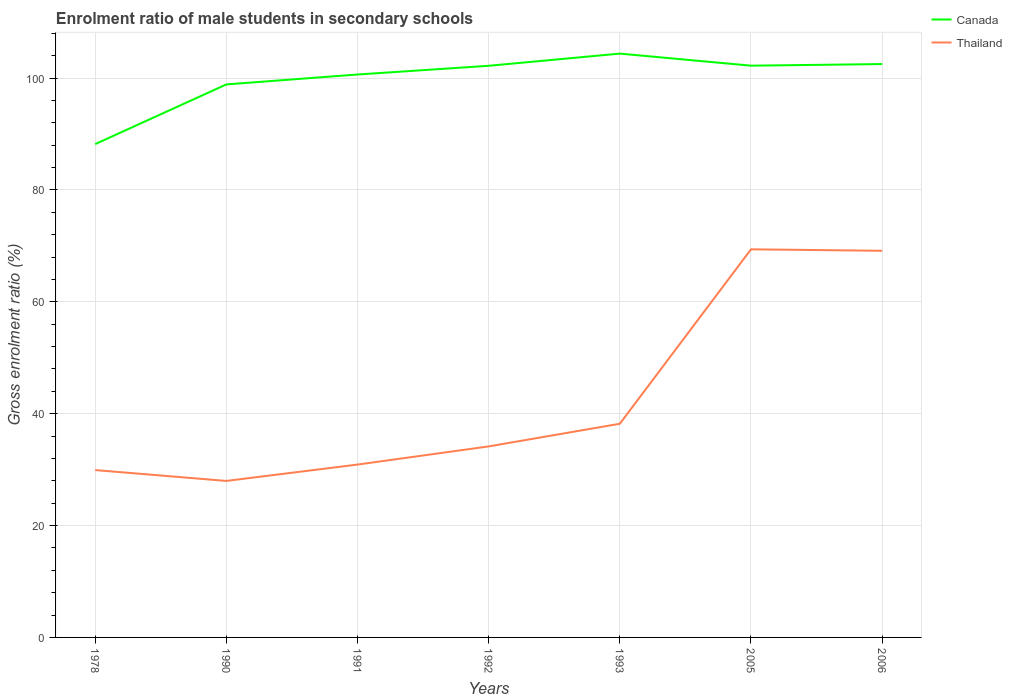How many different coloured lines are there?
Give a very brief answer. 2. Does the line corresponding to Thailand intersect with the line corresponding to Canada?
Make the answer very short. No. Across all years, what is the maximum enrolment ratio of male students in secondary schools in Thailand?
Ensure brevity in your answer.  27.98. What is the total enrolment ratio of male students in secondary schools in Canada in the graph?
Your answer should be very brief. -2.18. What is the difference between the highest and the second highest enrolment ratio of male students in secondary schools in Thailand?
Your answer should be compact. 41.41. What is the difference between the highest and the lowest enrolment ratio of male students in secondary schools in Canada?
Make the answer very short. 5. Are the values on the major ticks of Y-axis written in scientific E-notation?
Ensure brevity in your answer.  No. Where does the legend appear in the graph?
Provide a short and direct response. Top right. How many legend labels are there?
Make the answer very short. 2. What is the title of the graph?
Ensure brevity in your answer.  Enrolment ratio of male students in secondary schools. What is the label or title of the X-axis?
Ensure brevity in your answer.  Years. What is the Gross enrolment ratio (%) in Canada in 1978?
Make the answer very short. 88.2. What is the Gross enrolment ratio (%) in Thailand in 1978?
Offer a very short reply. 29.92. What is the Gross enrolment ratio (%) of Canada in 1990?
Give a very brief answer. 98.87. What is the Gross enrolment ratio (%) in Thailand in 1990?
Keep it short and to the point. 27.98. What is the Gross enrolment ratio (%) of Canada in 1991?
Provide a short and direct response. 100.64. What is the Gross enrolment ratio (%) of Thailand in 1991?
Keep it short and to the point. 30.91. What is the Gross enrolment ratio (%) in Canada in 1992?
Ensure brevity in your answer.  102.2. What is the Gross enrolment ratio (%) of Thailand in 1992?
Your response must be concise. 34.15. What is the Gross enrolment ratio (%) of Canada in 1993?
Your answer should be very brief. 104.38. What is the Gross enrolment ratio (%) in Thailand in 1993?
Give a very brief answer. 38.2. What is the Gross enrolment ratio (%) in Canada in 2005?
Give a very brief answer. 102.22. What is the Gross enrolment ratio (%) of Thailand in 2005?
Provide a succinct answer. 69.39. What is the Gross enrolment ratio (%) in Canada in 2006?
Make the answer very short. 102.51. What is the Gross enrolment ratio (%) of Thailand in 2006?
Offer a very short reply. 69.12. Across all years, what is the maximum Gross enrolment ratio (%) in Canada?
Your answer should be very brief. 104.38. Across all years, what is the maximum Gross enrolment ratio (%) in Thailand?
Keep it short and to the point. 69.39. Across all years, what is the minimum Gross enrolment ratio (%) in Canada?
Make the answer very short. 88.2. Across all years, what is the minimum Gross enrolment ratio (%) of Thailand?
Make the answer very short. 27.98. What is the total Gross enrolment ratio (%) in Canada in the graph?
Your answer should be compact. 699.02. What is the total Gross enrolment ratio (%) in Thailand in the graph?
Give a very brief answer. 299.67. What is the difference between the Gross enrolment ratio (%) of Canada in 1978 and that in 1990?
Your answer should be compact. -10.67. What is the difference between the Gross enrolment ratio (%) in Thailand in 1978 and that in 1990?
Give a very brief answer. 1.94. What is the difference between the Gross enrolment ratio (%) of Canada in 1978 and that in 1991?
Keep it short and to the point. -12.44. What is the difference between the Gross enrolment ratio (%) of Thailand in 1978 and that in 1991?
Keep it short and to the point. -0.99. What is the difference between the Gross enrolment ratio (%) of Canada in 1978 and that in 1992?
Ensure brevity in your answer.  -14. What is the difference between the Gross enrolment ratio (%) of Thailand in 1978 and that in 1992?
Make the answer very short. -4.23. What is the difference between the Gross enrolment ratio (%) in Canada in 1978 and that in 1993?
Offer a terse response. -16.18. What is the difference between the Gross enrolment ratio (%) in Thailand in 1978 and that in 1993?
Give a very brief answer. -8.28. What is the difference between the Gross enrolment ratio (%) in Canada in 1978 and that in 2005?
Give a very brief answer. -14.02. What is the difference between the Gross enrolment ratio (%) of Thailand in 1978 and that in 2005?
Your response must be concise. -39.47. What is the difference between the Gross enrolment ratio (%) in Canada in 1978 and that in 2006?
Keep it short and to the point. -14.31. What is the difference between the Gross enrolment ratio (%) in Thailand in 1978 and that in 2006?
Keep it short and to the point. -39.2. What is the difference between the Gross enrolment ratio (%) of Canada in 1990 and that in 1991?
Give a very brief answer. -1.77. What is the difference between the Gross enrolment ratio (%) of Thailand in 1990 and that in 1991?
Provide a succinct answer. -2.93. What is the difference between the Gross enrolment ratio (%) of Canada in 1990 and that in 1992?
Offer a terse response. -3.33. What is the difference between the Gross enrolment ratio (%) of Thailand in 1990 and that in 1992?
Provide a succinct answer. -6.17. What is the difference between the Gross enrolment ratio (%) in Canada in 1990 and that in 1993?
Your answer should be compact. -5.51. What is the difference between the Gross enrolment ratio (%) in Thailand in 1990 and that in 1993?
Offer a terse response. -10.22. What is the difference between the Gross enrolment ratio (%) in Canada in 1990 and that in 2005?
Provide a short and direct response. -3.35. What is the difference between the Gross enrolment ratio (%) in Thailand in 1990 and that in 2005?
Keep it short and to the point. -41.41. What is the difference between the Gross enrolment ratio (%) of Canada in 1990 and that in 2006?
Provide a short and direct response. -3.64. What is the difference between the Gross enrolment ratio (%) of Thailand in 1990 and that in 2006?
Offer a very short reply. -41.14. What is the difference between the Gross enrolment ratio (%) of Canada in 1991 and that in 1992?
Offer a terse response. -1.56. What is the difference between the Gross enrolment ratio (%) in Thailand in 1991 and that in 1992?
Make the answer very short. -3.25. What is the difference between the Gross enrolment ratio (%) in Canada in 1991 and that in 1993?
Provide a succinct answer. -3.73. What is the difference between the Gross enrolment ratio (%) in Thailand in 1991 and that in 1993?
Make the answer very short. -7.3. What is the difference between the Gross enrolment ratio (%) of Canada in 1991 and that in 2005?
Provide a succinct answer. -1.58. What is the difference between the Gross enrolment ratio (%) of Thailand in 1991 and that in 2005?
Give a very brief answer. -38.48. What is the difference between the Gross enrolment ratio (%) in Canada in 1991 and that in 2006?
Your answer should be very brief. -1.87. What is the difference between the Gross enrolment ratio (%) in Thailand in 1991 and that in 2006?
Offer a terse response. -38.22. What is the difference between the Gross enrolment ratio (%) in Canada in 1992 and that in 1993?
Your answer should be compact. -2.18. What is the difference between the Gross enrolment ratio (%) of Thailand in 1992 and that in 1993?
Ensure brevity in your answer.  -4.05. What is the difference between the Gross enrolment ratio (%) of Canada in 1992 and that in 2005?
Offer a very short reply. -0.02. What is the difference between the Gross enrolment ratio (%) in Thailand in 1992 and that in 2005?
Ensure brevity in your answer.  -35.24. What is the difference between the Gross enrolment ratio (%) of Canada in 1992 and that in 2006?
Your answer should be very brief. -0.31. What is the difference between the Gross enrolment ratio (%) of Thailand in 1992 and that in 2006?
Keep it short and to the point. -34.97. What is the difference between the Gross enrolment ratio (%) in Canada in 1993 and that in 2005?
Your answer should be very brief. 2.16. What is the difference between the Gross enrolment ratio (%) in Thailand in 1993 and that in 2005?
Your answer should be very brief. -31.19. What is the difference between the Gross enrolment ratio (%) of Canada in 1993 and that in 2006?
Offer a terse response. 1.87. What is the difference between the Gross enrolment ratio (%) of Thailand in 1993 and that in 2006?
Provide a short and direct response. -30.92. What is the difference between the Gross enrolment ratio (%) in Canada in 2005 and that in 2006?
Your response must be concise. -0.29. What is the difference between the Gross enrolment ratio (%) of Thailand in 2005 and that in 2006?
Your answer should be compact. 0.27. What is the difference between the Gross enrolment ratio (%) of Canada in 1978 and the Gross enrolment ratio (%) of Thailand in 1990?
Give a very brief answer. 60.22. What is the difference between the Gross enrolment ratio (%) of Canada in 1978 and the Gross enrolment ratio (%) of Thailand in 1991?
Offer a very short reply. 57.29. What is the difference between the Gross enrolment ratio (%) of Canada in 1978 and the Gross enrolment ratio (%) of Thailand in 1992?
Your answer should be very brief. 54.05. What is the difference between the Gross enrolment ratio (%) in Canada in 1978 and the Gross enrolment ratio (%) in Thailand in 1993?
Provide a short and direct response. 50. What is the difference between the Gross enrolment ratio (%) in Canada in 1978 and the Gross enrolment ratio (%) in Thailand in 2005?
Make the answer very short. 18.81. What is the difference between the Gross enrolment ratio (%) in Canada in 1978 and the Gross enrolment ratio (%) in Thailand in 2006?
Your answer should be very brief. 19.08. What is the difference between the Gross enrolment ratio (%) in Canada in 1990 and the Gross enrolment ratio (%) in Thailand in 1991?
Your answer should be very brief. 67.97. What is the difference between the Gross enrolment ratio (%) of Canada in 1990 and the Gross enrolment ratio (%) of Thailand in 1992?
Provide a short and direct response. 64.72. What is the difference between the Gross enrolment ratio (%) in Canada in 1990 and the Gross enrolment ratio (%) in Thailand in 1993?
Keep it short and to the point. 60.67. What is the difference between the Gross enrolment ratio (%) of Canada in 1990 and the Gross enrolment ratio (%) of Thailand in 2005?
Provide a short and direct response. 29.48. What is the difference between the Gross enrolment ratio (%) in Canada in 1990 and the Gross enrolment ratio (%) in Thailand in 2006?
Your answer should be very brief. 29.75. What is the difference between the Gross enrolment ratio (%) in Canada in 1991 and the Gross enrolment ratio (%) in Thailand in 1992?
Give a very brief answer. 66.49. What is the difference between the Gross enrolment ratio (%) in Canada in 1991 and the Gross enrolment ratio (%) in Thailand in 1993?
Make the answer very short. 62.44. What is the difference between the Gross enrolment ratio (%) of Canada in 1991 and the Gross enrolment ratio (%) of Thailand in 2005?
Make the answer very short. 31.25. What is the difference between the Gross enrolment ratio (%) of Canada in 1991 and the Gross enrolment ratio (%) of Thailand in 2006?
Ensure brevity in your answer.  31.52. What is the difference between the Gross enrolment ratio (%) of Canada in 1992 and the Gross enrolment ratio (%) of Thailand in 1993?
Provide a succinct answer. 64. What is the difference between the Gross enrolment ratio (%) in Canada in 1992 and the Gross enrolment ratio (%) in Thailand in 2005?
Your response must be concise. 32.81. What is the difference between the Gross enrolment ratio (%) in Canada in 1992 and the Gross enrolment ratio (%) in Thailand in 2006?
Keep it short and to the point. 33.08. What is the difference between the Gross enrolment ratio (%) in Canada in 1993 and the Gross enrolment ratio (%) in Thailand in 2005?
Offer a terse response. 34.99. What is the difference between the Gross enrolment ratio (%) of Canada in 1993 and the Gross enrolment ratio (%) of Thailand in 2006?
Your response must be concise. 35.25. What is the difference between the Gross enrolment ratio (%) in Canada in 2005 and the Gross enrolment ratio (%) in Thailand in 2006?
Your answer should be very brief. 33.1. What is the average Gross enrolment ratio (%) in Canada per year?
Make the answer very short. 99.86. What is the average Gross enrolment ratio (%) in Thailand per year?
Ensure brevity in your answer.  42.81. In the year 1978, what is the difference between the Gross enrolment ratio (%) of Canada and Gross enrolment ratio (%) of Thailand?
Make the answer very short. 58.28. In the year 1990, what is the difference between the Gross enrolment ratio (%) of Canada and Gross enrolment ratio (%) of Thailand?
Ensure brevity in your answer.  70.89. In the year 1991, what is the difference between the Gross enrolment ratio (%) in Canada and Gross enrolment ratio (%) in Thailand?
Give a very brief answer. 69.74. In the year 1992, what is the difference between the Gross enrolment ratio (%) of Canada and Gross enrolment ratio (%) of Thailand?
Give a very brief answer. 68.05. In the year 1993, what is the difference between the Gross enrolment ratio (%) in Canada and Gross enrolment ratio (%) in Thailand?
Offer a very short reply. 66.17. In the year 2005, what is the difference between the Gross enrolment ratio (%) of Canada and Gross enrolment ratio (%) of Thailand?
Offer a terse response. 32.83. In the year 2006, what is the difference between the Gross enrolment ratio (%) in Canada and Gross enrolment ratio (%) in Thailand?
Provide a succinct answer. 33.39. What is the ratio of the Gross enrolment ratio (%) of Canada in 1978 to that in 1990?
Offer a terse response. 0.89. What is the ratio of the Gross enrolment ratio (%) in Thailand in 1978 to that in 1990?
Your answer should be very brief. 1.07. What is the ratio of the Gross enrolment ratio (%) in Canada in 1978 to that in 1991?
Your answer should be very brief. 0.88. What is the ratio of the Gross enrolment ratio (%) of Thailand in 1978 to that in 1991?
Keep it short and to the point. 0.97. What is the ratio of the Gross enrolment ratio (%) of Canada in 1978 to that in 1992?
Keep it short and to the point. 0.86. What is the ratio of the Gross enrolment ratio (%) of Thailand in 1978 to that in 1992?
Provide a short and direct response. 0.88. What is the ratio of the Gross enrolment ratio (%) in Canada in 1978 to that in 1993?
Offer a terse response. 0.84. What is the ratio of the Gross enrolment ratio (%) of Thailand in 1978 to that in 1993?
Your response must be concise. 0.78. What is the ratio of the Gross enrolment ratio (%) of Canada in 1978 to that in 2005?
Your answer should be very brief. 0.86. What is the ratio of the Gross enrolment ratio (%) in Thailand in 1978 to that in 2005?
Offer a very short reply. 0.43. What is the ratio of the Gross enrolment ratio (%) of Canada in 1978 to that in 2006?
Make the answer very short. 0.86. What is the ratio of the Gross enrolment ratio (%) in Thailand in 1978 to that in 2006?
Provide a short and direct response. 0.43. What is the ratio of the Gross enrolment ratio (%) of Canada in 1990 to that in 1991?
Offer a terse response. 0.98. What is the ratio of the Gross enrolment ratio (%) in Thailand in 1990 to that in 1991?
Provide a succinct answer. 0.91. What is the ratio of the Gross enrolment ratio (%) in Canada in 1990 to that in 1992?
Keep it short and to the point. 0.97. What is the ratio of the Gross enrolment ratio (%) in Thailand in 1990 to that in 1992?
Ensure brevity in your answer.  0.82. What is the ratio of the Gross enrolment ratio (%) in Canada in 1990 to that in 1993?
Ensure brevity in your answer.  0.95. What is the ratio of the Gross enrolment ratio (%) in Thailand in 1990 to that in 1993?
Make the answer very short. 0.73. What is the ratio of the Gross enrolment ratio (%) in Canada in 1990 to that in 2005?
Keep it short and to the point. 0.97. What is the ratio of the Gross enrolment ratio (%) of Thailand in 1990 to that in 2005?
Your answer should be very brief. 0.4. What is the ratio of the Gross enrolment ratio (%) in Canada in 1990 to that in 2006?
Offer a very short reply. 0.96. What is the ratio of the Gross enrolment ratio (%) in Thailand in 1990 to that in 2006?
Your response must be concise. 0.4. What is the ratio of the Gross enrolment ratio (%) of Thailand in 1991 to that in 1992?
Provide a succinct answer. 0.9. What is the ratio of the Gross enrolment ratio (%) in Canada in 1991 to that in 1993?
Make the answer very short. 0.96. What is the ratio of the Gross enrolment ratio (%) of Thailand in 1991 to that in 1993?
Your answer should be very brief. 0.81. What is the ratio of the Gross enrolment ratio (%) in Canada in 1991 to that in 2005?
Your answer should be compact. 0.98. What is the ratio of the Gross enrolment ratio (%) in Thailand in 1991 to that in 2005?
Make the answer very short. 0.45. What is the ratio of the Gross enrolment ratio (%) in Canada in 1991 to that in 2006?
Provide a short and direct response. 0.98. What is the ratio of the Gross enrolment ratio (%) in Thailand in 1991 to that in 2006?
Give a very brief answer. 0.45. What is the ratio of the Gross enrolment ratio (%) in Canada in 1992 to that in 1993?
Provide a succinct answer. 0.98. What is the ratio of the Gross enrolment ratio (%) in Thailand in 1992 to that in 1993?
Your response must be concise. 0.89. What is the ratio of the Gross enrolment ratio (%) of Canada in 1992 to that in 2005?
Keep it short and to the point. 1. What is the ratio of the Gross enrolment ratio (%) of Thailand in 1992 to that in 2005?
Your answer should be very brief. 0.49. What is the ratio of the Gross enrolment ratio (%) of Thailand in 1992 to that in 2006?
Ensure brevity in your answer.  0.49. What is the ratio of the Gross enrolment ratio (%) of Canada in 1993 to that in 2005?
Keep it short and to the point. 1.02. What is the ratio of the Gross enrolment ratio (%) of Thailand in 1993 to that in 2005?
Your answer should be very brief. 0.55. What is the ratio of the Gross enrolment ratio (%) of Canada in 1993 to that in 2006?
Your response must be concise. 1.02. What is the ratio of the Gross enrolment ratio (%) of Thailand in 1993 to that in 2006?
Provide a succinct answer. 0.55. What is the ratio of the Gross enrolment ratio (%) in Thailand in 2005 to that in 2006?
Give a very brief answer. 1. What is the difference between the highest and the second highest Gross enrolment ratio (%) of Canada?
Your answer should be compact. 1.87. What is the difference between the highest and the second highest Gross enrolment ratio (%) in Thailand?
Make the answer very short. 0.27. What is the difference between the highest and the lowest Gross enrolment ratio (%) of Canada?
Ensure brevity in your answer.  16.18. What is the difference between the highest and the lowest Gross enrolment ratio (%) in Thailand?
Your answer should be compact. 41.41. 